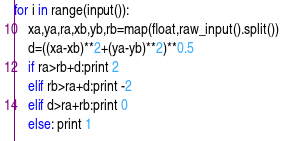Convert code to text. <code><loc_0><loc_0><loc_500><loc_500><_Python_>for i in range(input()):
    xa,ya,ra,xb,yb,rb=map(float,raw_input().split())
    d=((xa-xb)**2+(ya-yb)**2)**0.5
    if ra>rb+d:print 2
    elif rb>ra+d:print -2
    elif d>ra+rb:print 0
    else: print 1</code> 